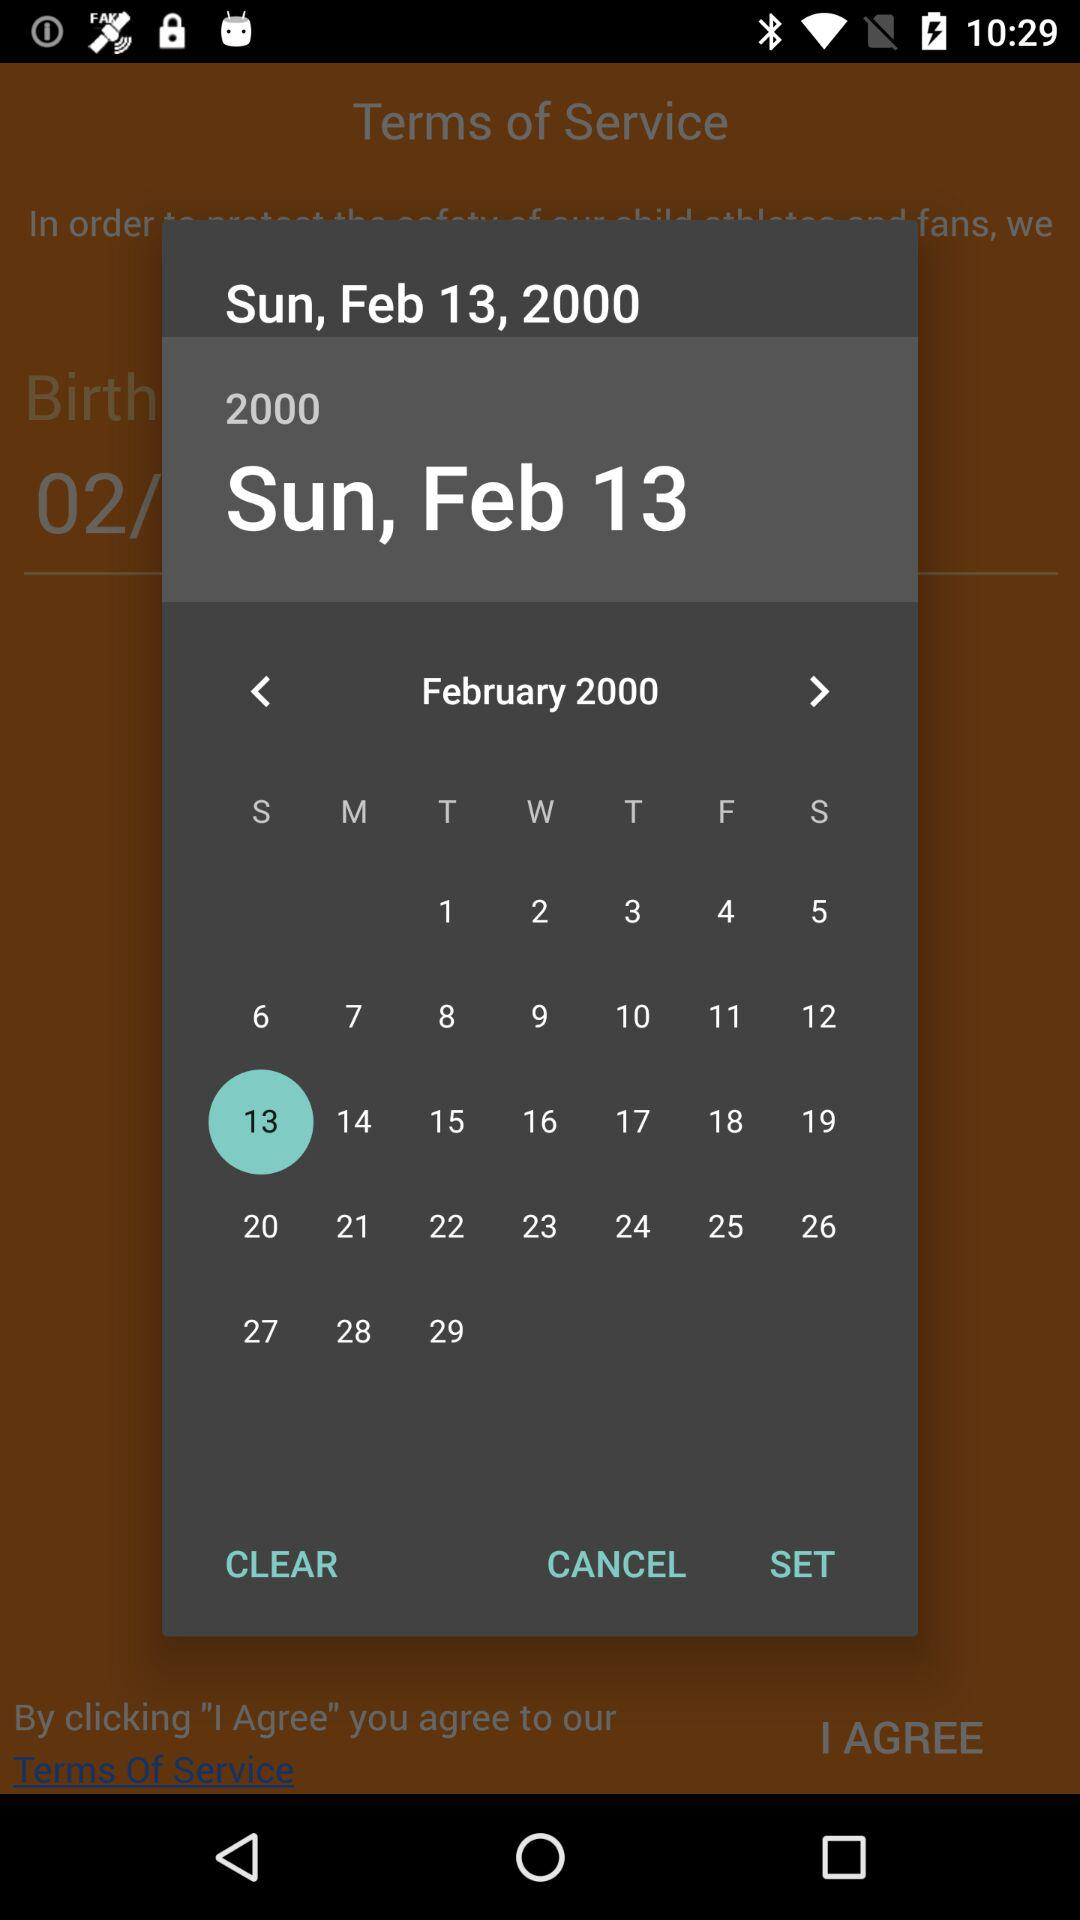What day is the 4th of February? The day is Friday. 